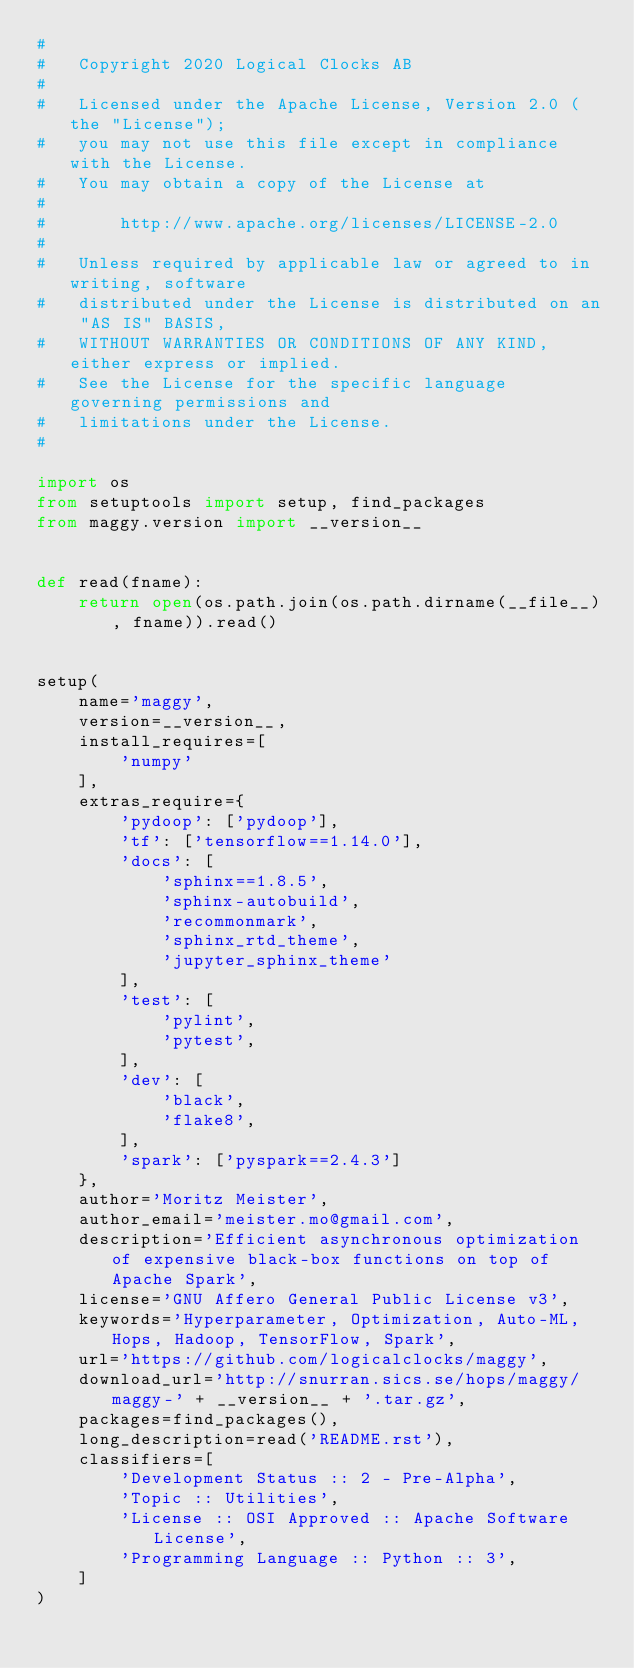<code> <loc_0><loc_0><loc_500><loc_500><_Python_>#
#   Copyright 2020 Logical Clocks AB
#
#   Licensed under the Apache License, Version 2.0 (the "License");
#   you may not use this file except in compliance with the License.
#   You may obtain a copy of the License at
#
#       http://www.apache.org/licenses/LICENSE-2.0
#
#   Unless required by applicable law or agreed to in writing, software
#   distributed under the License is distributed on an "AS IS" BASIS,
#   WITHOUT WARRANTIES OR CONDITIONS OF ANY KIND, either express or implied.
#   See the License for the specific language governing permissions and
#   limitations under the License.
#

import os
from setuptools import setup, find_packages
from maggy.version import __version__


def read(fname):
    return open(os.path.join(os.path.dirname(__file__), fname)).read()


setup(
    name='maggy',
    version=__version__,
    install_requires=[
        'numpy'
    ],
    extras_require={
        'pydoop': ['pydoop'],
        'tf': ['tensorflow==1.14.0'],
        'docs': [
            'sphinx==1.8.5',
            'sphinx-autobuild',
            'recommonmark',
            'sphinx_rtd_theme',
            'jupyter_sphinx_theme'
        ],
        'test': [
            'pylint',
            'pytest',
        ],
        'dev': [
            'black',
            'flake8',
        ],
        'spark': ['pyspark==2.4.3']
    },
    author='Moritz Meister',
    author_email='meister.mo@gmail.com',
    description='Efficient asynchronous optimization of expensive black-box functions on top of Apache Spark',
    license='GNU Affero General Public License v3',
    keywords='Hyperparameter, Optimization, Auto-ML, Hops, Hadoop, TensorFlow, Spark',
    url='https://github.com/logicalclocks/maggy',
    download_url='http://snurran.sics.se/hops/maggy/maggy-' + __version__ + '.tar.gz',
    packages=find_packages(),
    long_description=read('README.rst'),
    classifiers=[
        'Development Status :: 2 - Pre-Alpha',
        'Topic :: Utilities',
        'License :: OSI Approved :: Apache Software License',
        'Programming Language :: Python :: 3',
    ]
)
</code> 